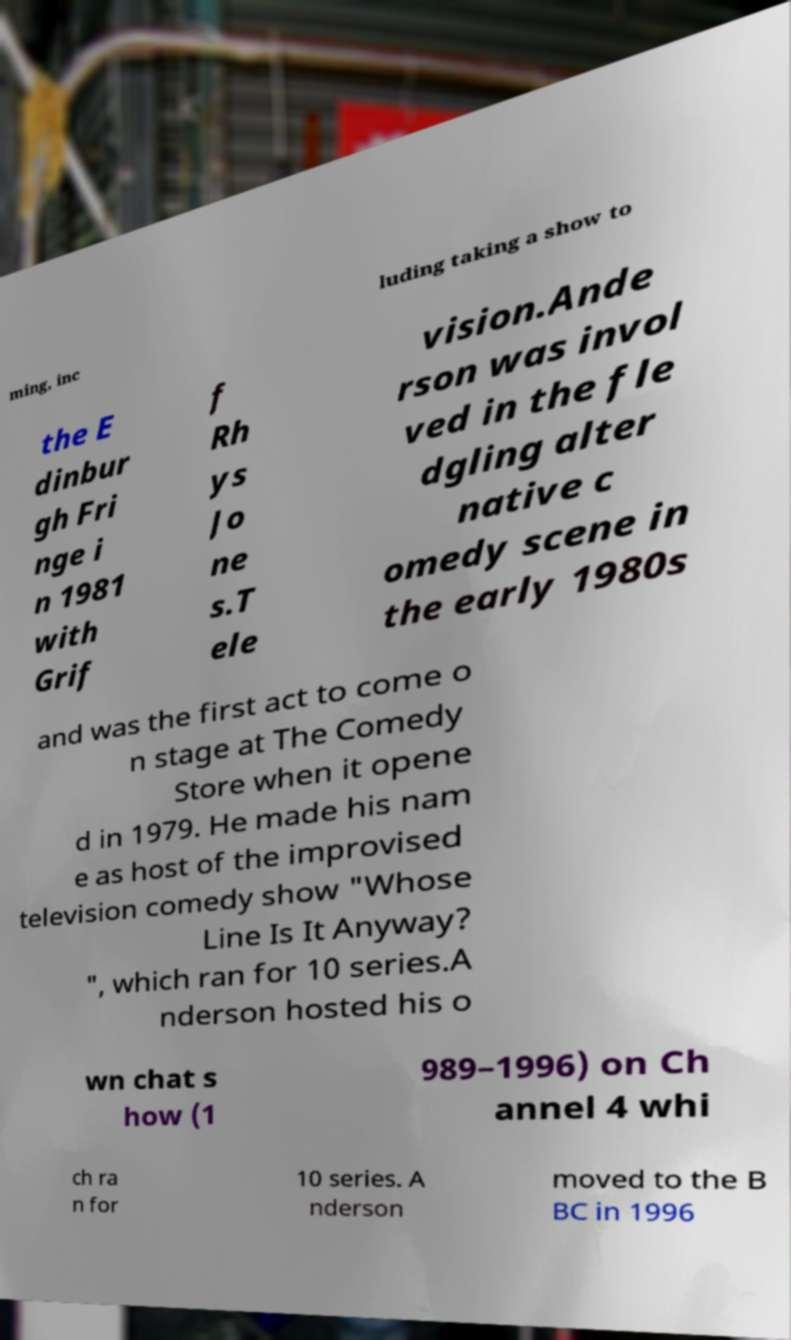Could you extract and type out the text from this image? ming, inc luding taking a show to the E dinbur gh Fri nge i n 1981 with Grif f Rh ys Jo ne s.T ele vision.Ande rson was invol ved in the fle dgling alter native c omedy scene in the early 1980s and was the first act to come o n stage at The Comedy Store when it opene d in 1979. He made his nam e as host of the improvised television comedy show "Whose Line Is It Anyway? ", which ran for 10 series.A nderson hosted his o wn chat s how (1 989–1996) on Ch annel 4 whi ch ra n for 10 series. A nderson moved to the B BC in 1996 